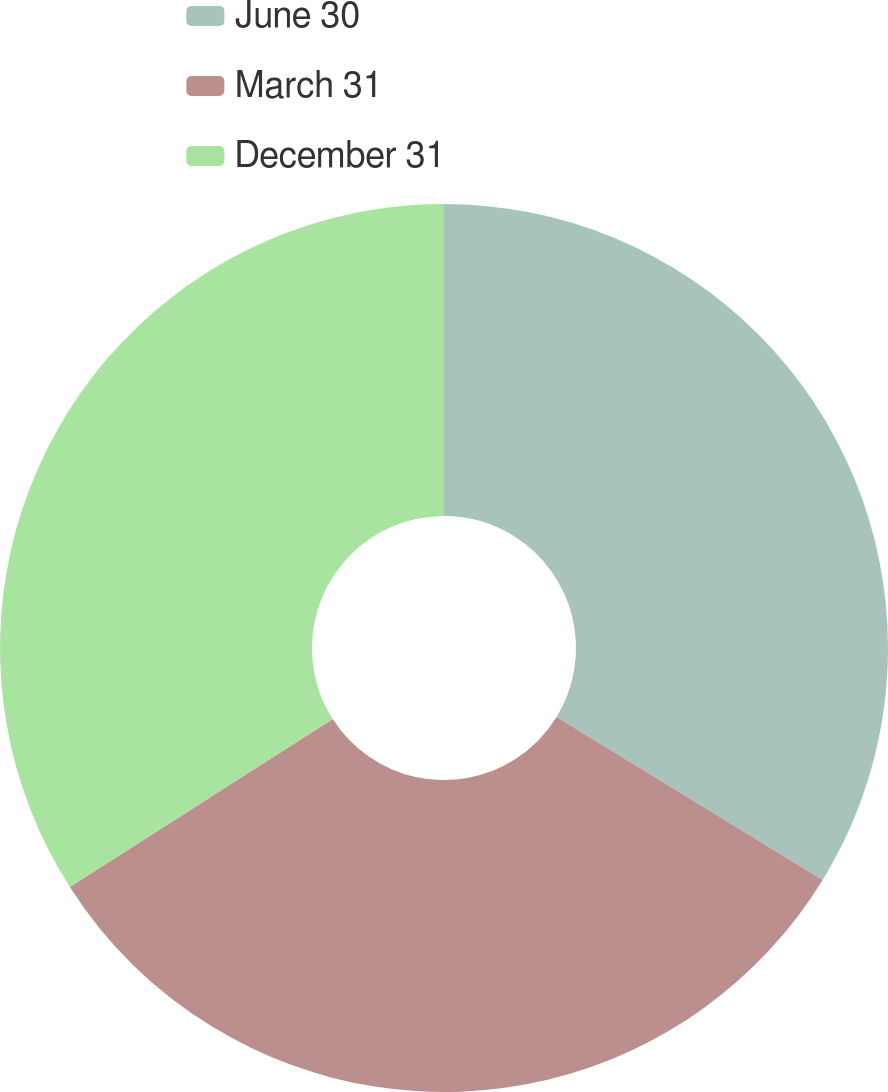<chart> <loc_0><loc_0><loc_500><loc_500><pie_chart><fcel>June 30<fcel>March 31<fcel>December 31<nl><fcel>33.75%<fcel>32.21%<fcel>34.05%<nl></chart> 